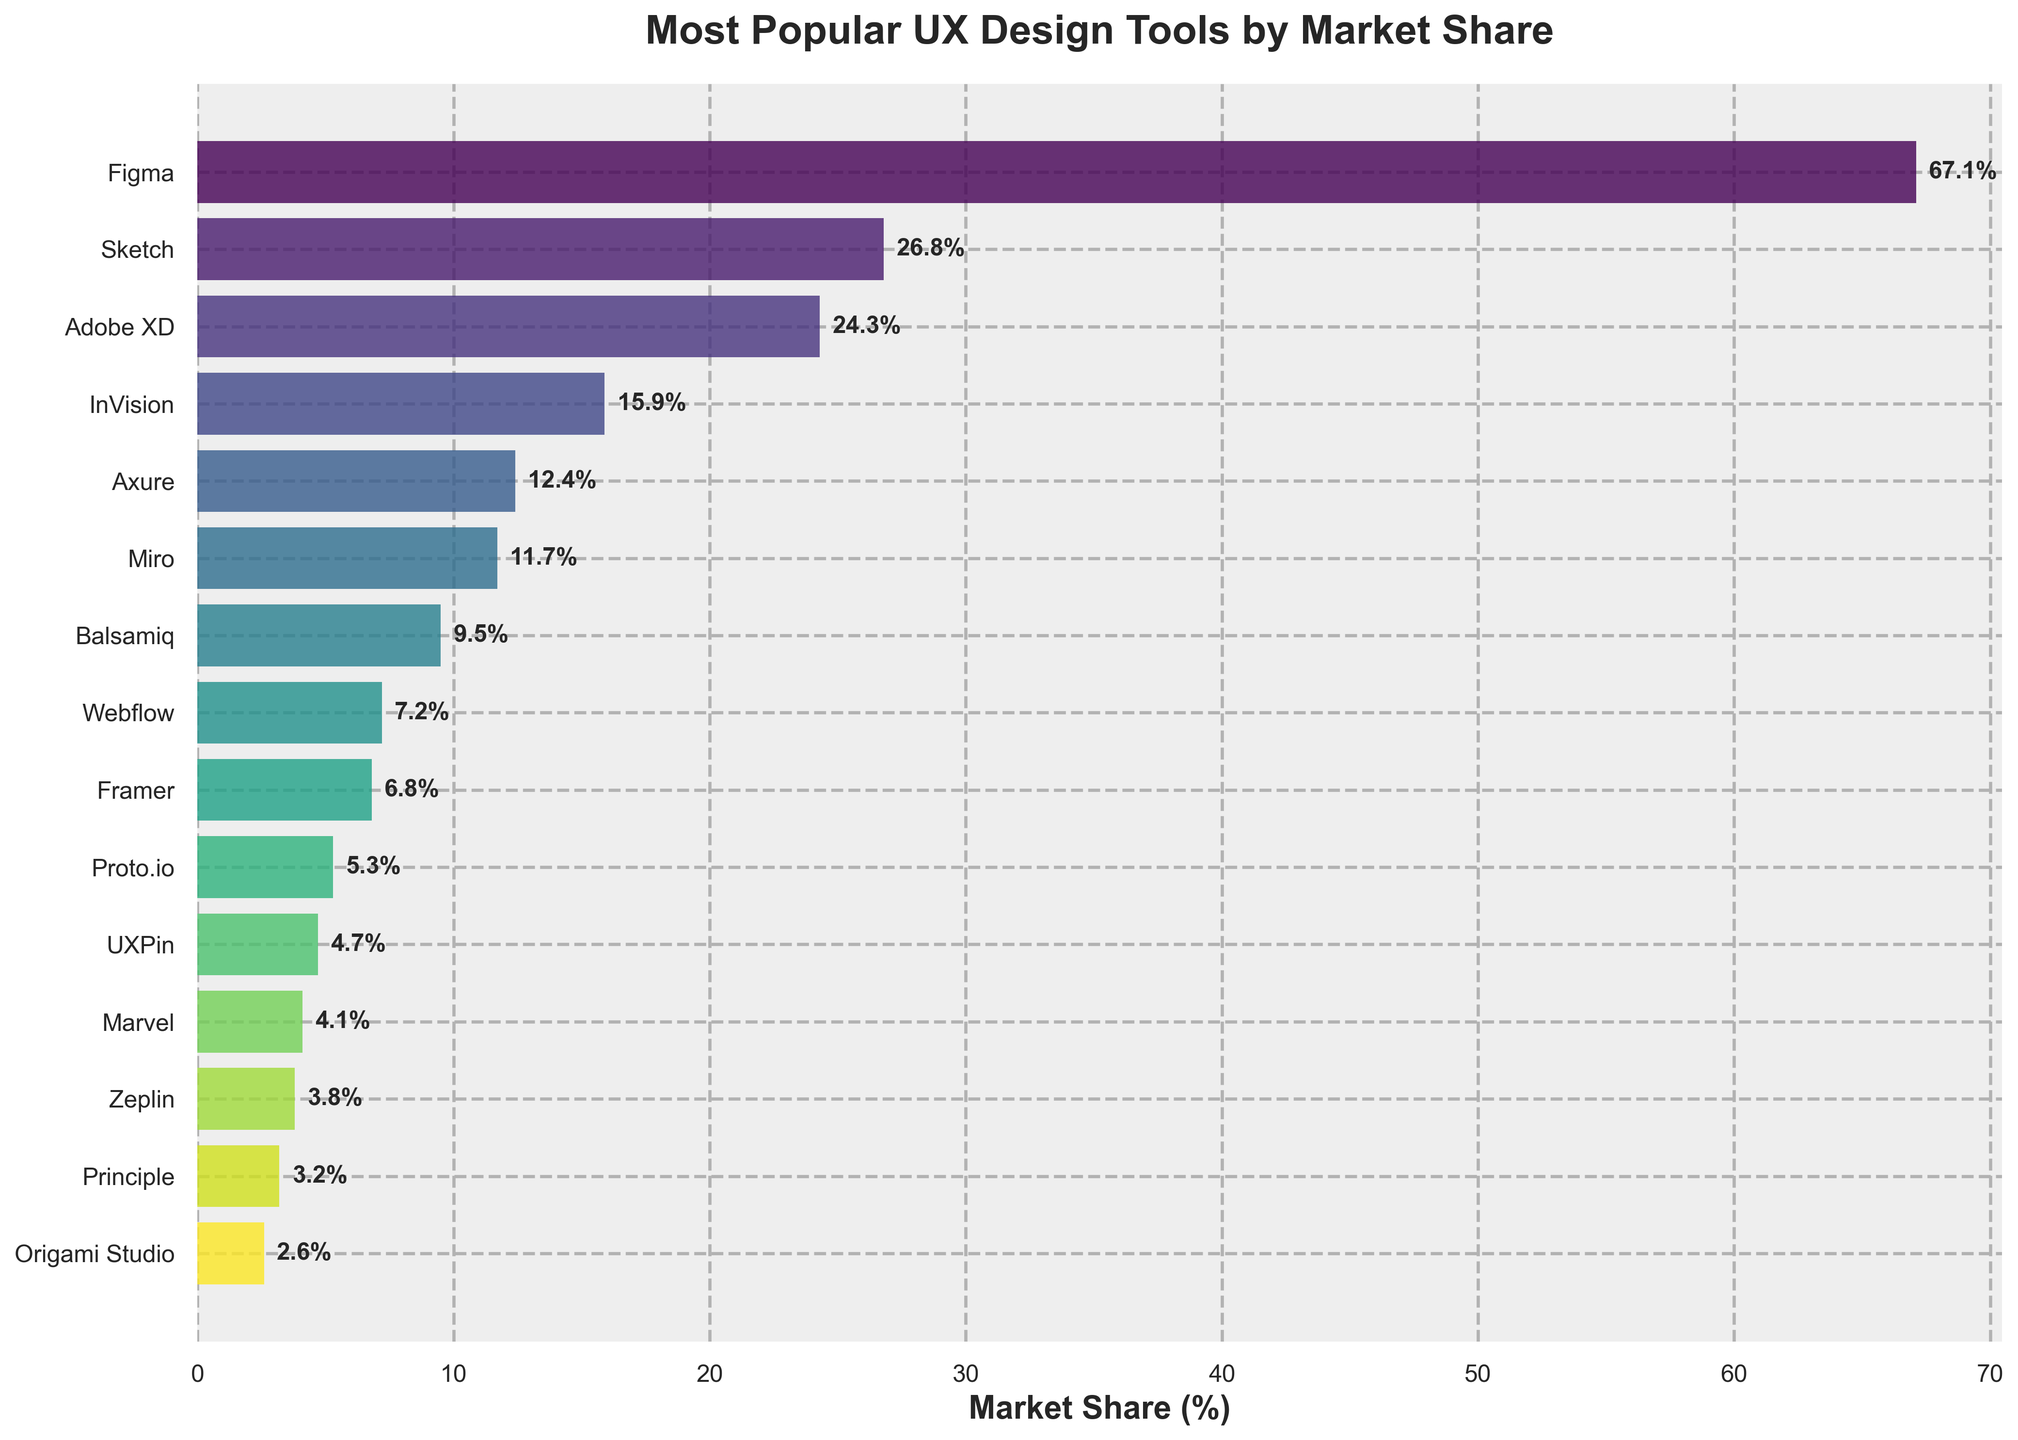Which UX design tool has the highest market share? Look for the tallest bar in the horizontal bar chart, which represents the tool with the highest market share. This tool is Figma.
Answer: Figma Which two UX design tools have the smallest difference in their market share? To answer this, find the tools with the closest market share values by comparing all pairs. The smallest difference is between Framer (6.8%) and Webflow (7.2%) with a difference of 0.4%.
Answer: Framer and Webflow How much greater is the market share of Adobe XD compared to Axure? Subtract the market share of Axure (12.4%) from Adobe XD (24.3%). The difference is 24.3% - 12.4% = 11.9%.
Answer: 11.9% Which UX design tools have a market share less than 10%? Identify the bars that fall below the 10% mark. These tools are Webflow, Framer, Proto.io, UXPin, Marvel, Zeplin, Principle, and Origami Studio.
Answer: Webflow, Framer, Proto.io, UXPin, Marvel, Zeplin, Principle, Origami Studio What is the total market share of the top three UX design tools? Sum the market share values of the top three tools: Figma (67.1%), Sketch (26.8%), and Adobe XD (24.3%). 67.1% + 26.8% + 24.3% = 118.2%.
Answer: 118.2% Among Miro, Balsamiq, and InVision, which tool has the highest market share? Compare the market shares of Miro (11.7%), Balsamiq (9.5%), and InVision (15.9%). The one with the highest value is InVision.
Answer: InVision What is the market share difference between UXPin and Marvel? Subtract the market share of Marvel (4.1%) from UXPin (4.7%). The difference is 4.7% - 4.1% = 0.6%.
Answer: 0.6% Which tool's market share is closest to 10%? Find the tool whose market share is nearest to 10%. Axure has 12.4%, which is the closest.
Answer: Axure If you combine the market share of the bottom five tools, what would be the total market share? Sum the market shares of the bottom five tools: Proto.io (5.3%), UXPin (4.7%), Marvel (4.1%), Zeplin (3.8%), and Principle (3.2%). The total is 5.3% + 4.7% + 4.1% + 3.8% + 3.2% = 21.1%.
Answer: 21.1% Which tool has a market share that is exactly 1/6th of Figma's market share? Calculate 1/6th of Figma’s market share (67.1%), which is 67.1% / 6 ≈ 11.2%. The closest tool to this market share is Miro with 11.7%.
Answer: Miro 